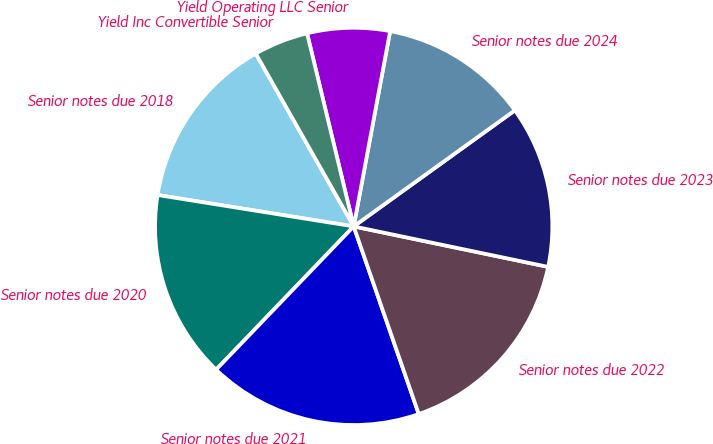Convert chart. <chart><loc_0><loc_0><loc_500><loc_500><pie_chart><fcel>Senior notes due 2018<fcel>Senior notes due 2020<fcel>Senior notes due 2021<fcel>Senior notes due 2022<fcel>Senior notes due 2023<fcel>Senior notes due 2024<fcel>Yield Operating LLC Senior<fcel>Yield Inc Convertible Senior<nl><fcel>14.27%<fcel>15.35%<fcel>17.49%<fcel>16.42%<fcel>13.2%<fcel>12.13%<fcel>6.71%<fcel>4.43%<nl></chart> 